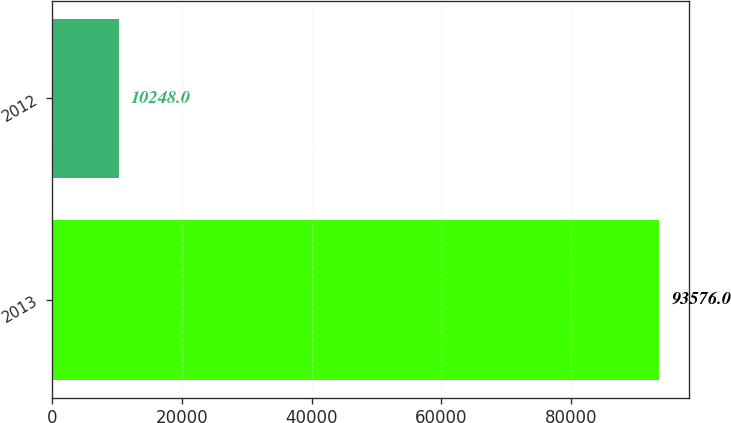<chart> <loc_0><loc_0><loc_500><loc_500><bar_chart><fcel>2013<fcel>2012<nl><fcel>93576<fcel>10248<nl></chart> 